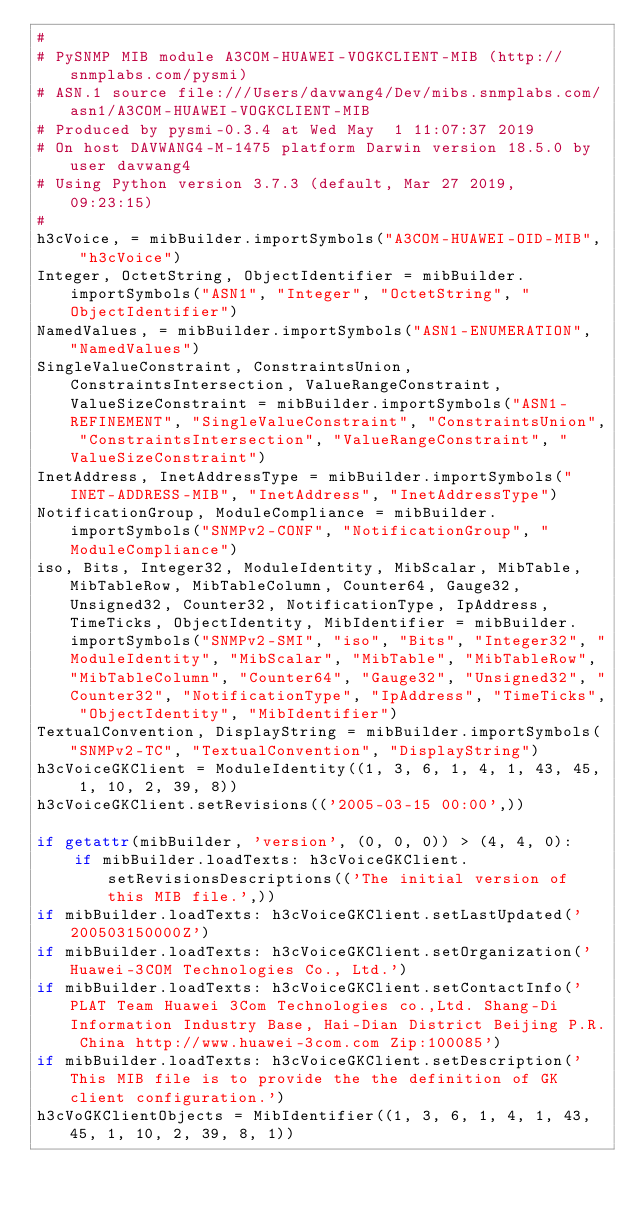<code> <loc_0><loc_0><loc_500><loc_500><_Python_>#
# PySNMP MIB module A3COM-HUAWEI-VOGKCLIENT-MIB (http://snmplabs.com/pysmi)
# ASN.1 source file:///Users/davwang4/Dev/mibs.snmplabs.com/asn1/A3COM-HUAWEI-VOGKCLIENT-MIB
# Produced by pysmi-0.3.4 at Wed May  1 11:07:37 2019
# On host DAVWANG4-M-1475 platform Darwin version 18.5.0 by user davwang4
# Using Python version 3.7.3 (default, Mar 27 2019, 09:23:15) 
#
h3cVoice, = mibBuilder.importSymbols("A3COM-HUAWEI-OID-MIB", "h3cVoice")
Integer, OctetString, ObjectIdentifier = mibBuilder.importSymbols("ASN1", "Integer", "OctetString", "ObjectIdentifier")
NamedValues, = mibBuilder.importSymbols("ASN1-ENUMERATION", "NamedValues")
SingleValueConstraint, ConstraintsUnion, ConstraintsIntersection, ValueRangeConstraint, ValueSizeConstraint = mibBuilder.importSymbols("ASN1-REFINEMENT", "SingleValueConstraint", "ConstraintsUnion", "ConstraintsIntersection", "ValueRangeConstraint", "ValueSizeConstraint")
InetAddress, InetAddressType = mibBuilder.importSymbols("INET-ADDRESS-MIB", "InetAddress", "InetAddressType")
NotificationGroup, ModuleCompliance = mibBuilder.importSymbols("SNMPv2-CONF", "NotificationGroup", "ModuleCompliance")
iso, Bits, Integer32, ModuleIdentity, MibScalar, MibTable, MibTableRow, MibTableColumn, Counter64, Gauge32, Unsigned32, Counter32, NotificationType, IpAddress, TimeTicks, ObjectIdentity, MibIdentifier = mibBuilder.importSymbols("SNMPv2-SMI", "iso", "Bits", "Integer32", "ModuleIdentity", "MibScalar", "MibTable", "MibTableRow", "MibTableColumn", "Counter64", "Gauge32", "Unsigned32", "Counter32", "NotificationType", "IpAddress", "TimeTicks", "ObjectIdentity", "MibIdentifier")
TextualConvention, DisplayString = mibBuilder.importSymbols("SNMPv2-TC", "TextualConvention", "DisplayString")
h3cVoiceGKClient = ModuleIdentity((1, 3, 6, 1, 4, 1, 43, 45, 1, 10, 2, 39, 8))
h3cVoiceGKClient.setRevisions(('2005-03-15 00:00',))

if getattr(mibBuilder, 'version', (0, 0, 0)) > (4, 4, 0):
    if mibBuilder.loadTexts: h3cVoiceGKClient.setRevisionsDescriptions(('The initial version of this MIB file.',))
if mibBuilder.loadTexts: h3cVoiceGKClient.setLastUpdated('200503150000Z')
if mibBuilder.loadTexts: h3cVoiceGKClient.setOrganization('Huawei-3COM Technologies Co., Ltd.')
if mibBuilder.loadTexts: h3cVoiceGKClient.setContactInfo('PLAT Team Huawei 3Com Technologies co.,Ltd. Shang-Di Information Industry Base, Hai-Dian District Beijing P.R. China http://www.huawei-3com.com Zip:100085')
if mibBuilder.loadTexts: h3cVoiceGKClient.setDescription('This MIB file is to provide the the definition of GK client configuration.')
h3cVoGKClientObjects = MibIdentifier((1, 3, 6, 1, 4, 1, 43, 45, 1, 10, 2, 39, 8, 1))</code> 